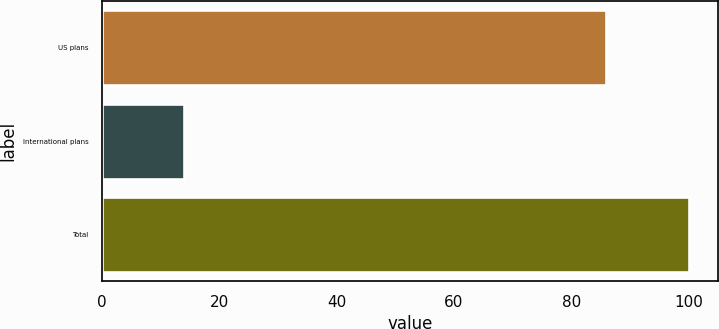<chart> <loc_0><loc_0><loc_500><loc_500><bar_chart><fcel>US plans<fcel>International plans<fcel>Total<nl><fcel>86<fcel>14<fcel>100<nl></chart> 